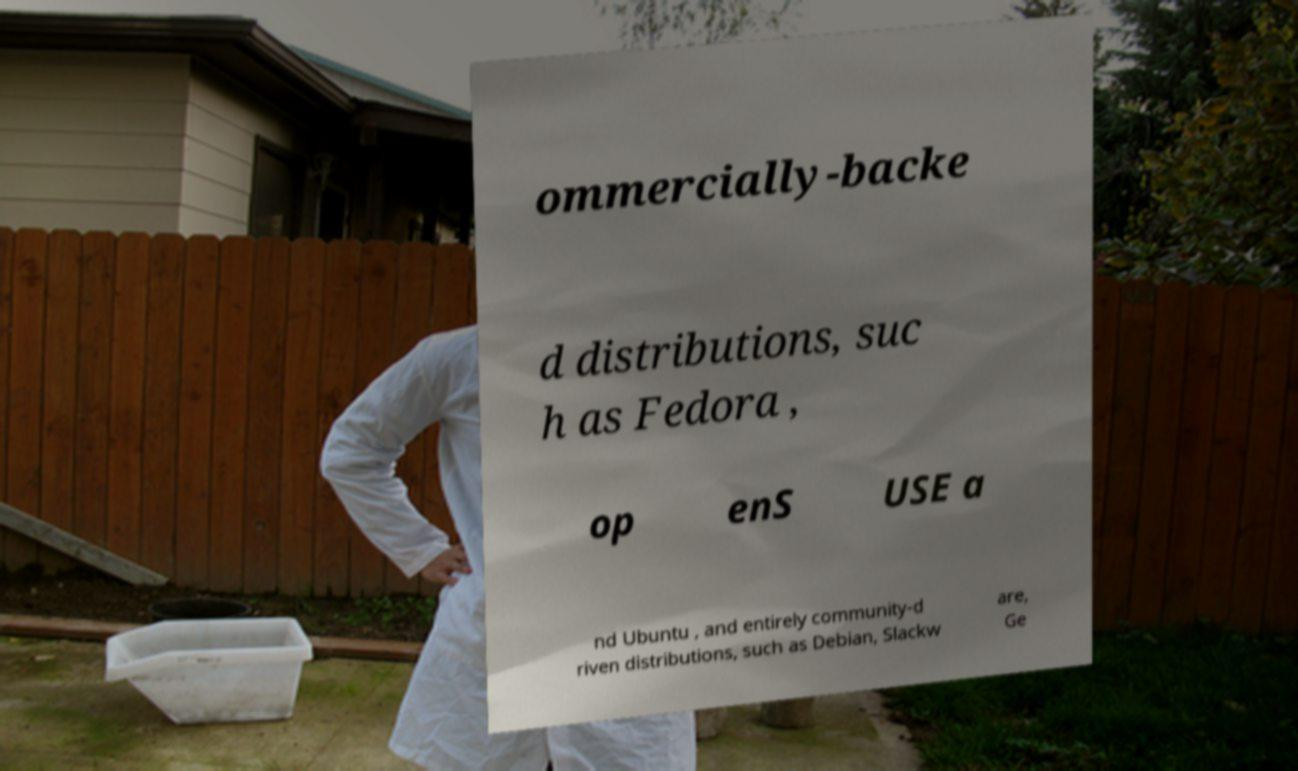Can you read and provide the text displayed in the image?This photo seems to have some interesting text. Can you extract and type it out for me? ommercially-backe d distributions, suc h as Fedora , op enS USE a nd Ubuntu , and entirely community-d riven distributions, such as Debian, Slackw are, Ge 